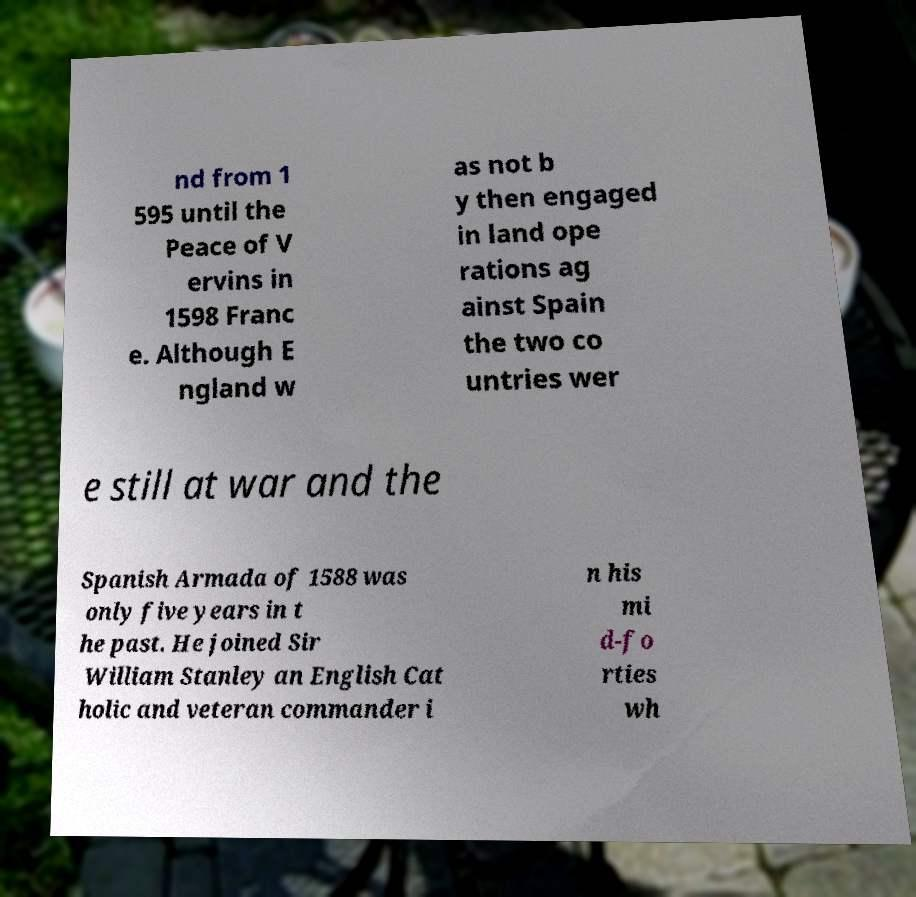Please read and relay the text visible in this image. What does it say? nd from 1 595 until the Peace of V ervins in 1598 Franc e. Although E ngland w as not b y then engaged in land ope rations ag ainst Spain the two co untries wer e still at war and the Spanish Armada of 1588 was only five years in t he past. He joined Sir William Stanley an English Cat holic and veteran commander i n his mi d-fo rties wh 